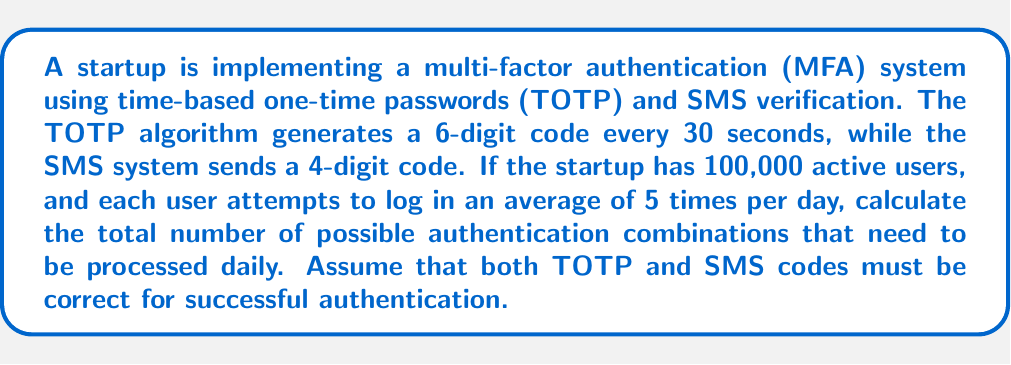Give your solution to this math problem. To solve this problem, we need to follow these steps:

1. Calculate the number of possible TOTP combinations:
   - TOTP generates a 6-digit code, so there are $10^6 = 1,000,000$ possible combinations.

2. Calculate the number of possible SMS combinations:
   - SMS sends a 4-digit code, so there are $10^4 = 10,000$ possible combinations.

3. Calculate the total number of possible combinations for one authentication attempt:
   - Since both TOTP and SMS must be correct, we multiply their combinations:
   $$1,000,000 \times 10,000 = 10,000,000,000$$

4. Calculate the total number of authentication attempts per day:
   - Number of users: 100,000
   - Average login attempts per user per day: 5
   - Total daily authentication attempts: $100,000 \times 5 = 500,000$

5. Calculate the total number of possible authentication combinations processed daily:
   - Multiply the number of combinations per attempt by the total daily attempts:
   $$10,000,000,000 \times 500,000 = 5 \times 10^{15}$$

Therefore, the startup's MFA system needs to process $5 \times 10^{15}$ possible authentication combinations daily.
Answer: $5 \times 10^{15}$ possible authentication combinations per day 